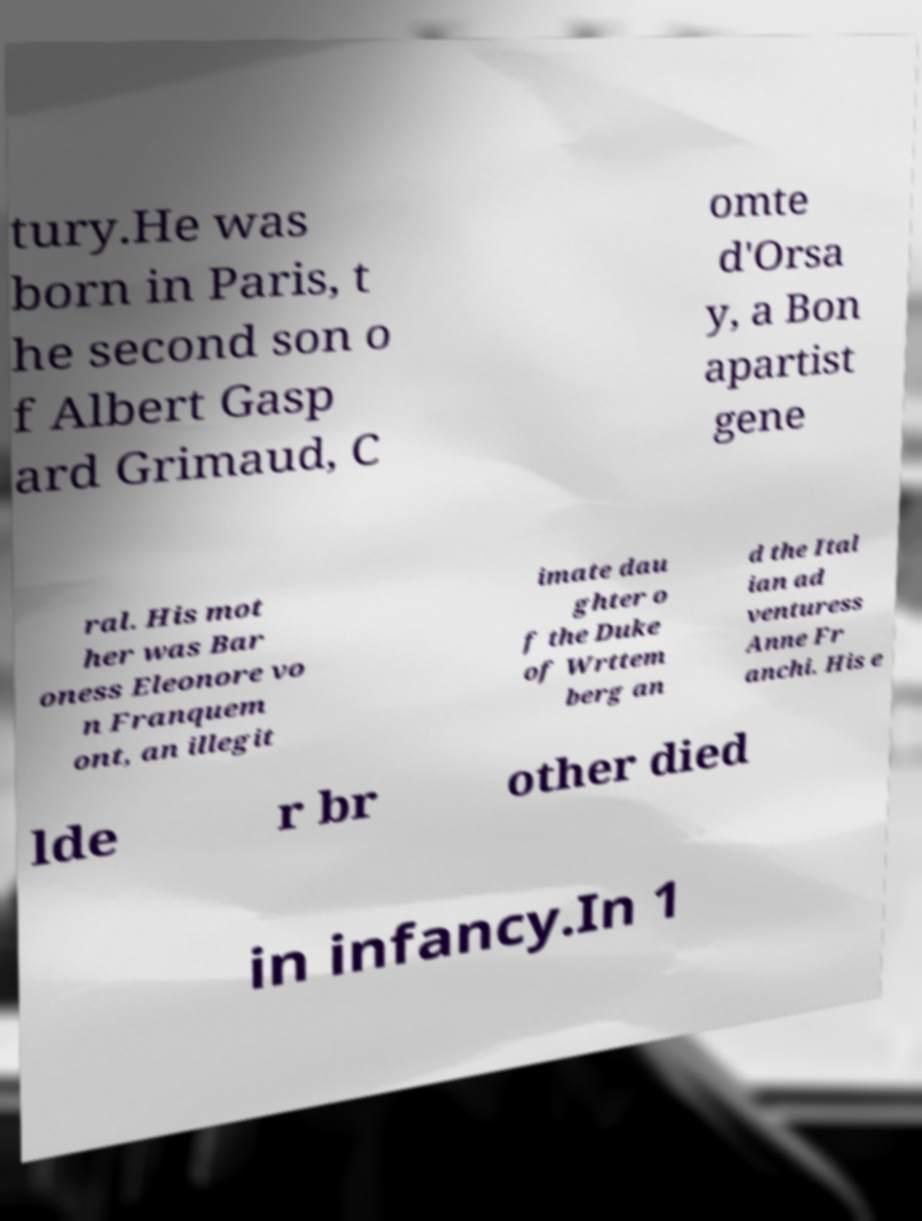There's text embedded in this image that I need extracted. Can you transcribe it verbatim? tury.He was born in Paris, t he second son o f Albert Gasp ard Grimaud, C omte d'Orsa y, a Bon apartist gene ral. His mot her was Bar oness Eleonore vo n Franquem ont, an illegit imate dau ghter o f the Duke of Wrttem berg an d the Ital ian ad venturess Anne Fr anchi. His e lde r br other died in infancy.In 1 